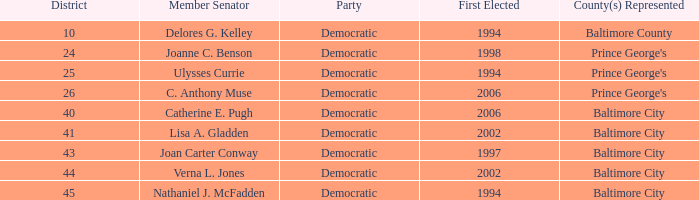What district for ulysses currie? 25.0. Write the full table. {'header': ['District', 'Member Senator', 'Party', 'First Elected', 'County(s) Represented'], 'rows': [['10', 'Delores G. Kelley', 'Democratic', '1994', 'Baltimore County'], ['24', 'Joanne C. Benson', 'Democratic', '1998', "Prince George's"], ['25', 'Ulysses Currie', 'Democratic', '1994', "Prince George's"], ['26', 'C. Anthony Muse', 'Democratic', '2006', "Prince George's"], ['40', 'Catherine E. Pugh', 'Democratic', '2006', 'Baltimore City'], ['41', 'Lisa A. Gladden', 'Democratic', '2002', 'Baltimore City'], ['43', 'Joan Carter Conway', 'Democratic', '1997', 'Baltimore City'], ['44', 'Verna L. Jones', 'Democratic', '2002', 'Baltimore City'], ['45', 'Nathaniel J. McFadden', 'Democratic', '1994', 'Baltimore City']]} 